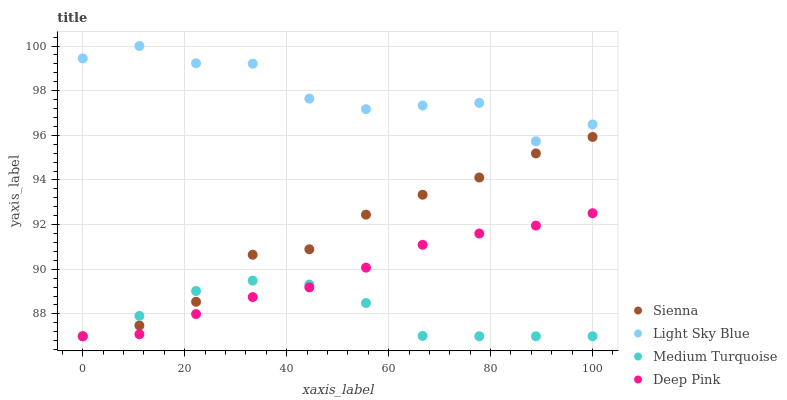Does Medium Turquoise have the minimum area under the curve?
Answer yes or no. Yes. Does Light Sky Blue have the maximum area under the curve?
Answer yes or no. Yes. Does Light Sky Blue have the minimum area under the curve?
Answer yes or no. No. Does Medium Turquoise have the maximum area under the curve?
Answer yes or no. No. Is Deep Pink the smoothest?
Answer yes or no. Yes. Is Light Sky Blue the roughest?
Answer yes or no. Yes. Is Medium Turquoise the smoothest?
Answer yes or no. No. Is Medium Turquoise the roughest?
Answer yes or no. No. Does Sienna have the lowest value?
Answer yes or no. Yes. Does Light Sky Blue have the lowest value?
Answer yes or no. No. Does Light Sky Blue have the highest value?
Answer yes or no. Yes. Does Medium Turquoise have the highest value?
Answer yes or no. No. Is Deep Pink less than Light Sky Blue?
Answer yes or no. Yes. Is Light Sky Blue greater than Sienna?
Answer yes or no. Yes. Does Medium Turquoise intersect Sienna?
Answer yes or no. Yes. Is Medium Turquoise less than Sienna?
Answer yes or no. No. Is Medium Turquoise greater than Sienna?
Answer yes or no. No. Does Deep Pink intersect Light Sky Blue?
Answer yes or no. No. 